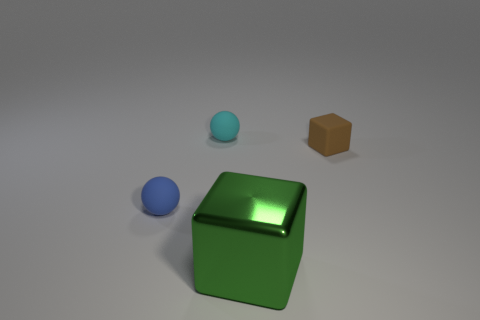How big is the thing that is to the left of the sphere right of the blue rubber sphere?
Offer a terse response. Small. How many brown things have the same shape as the tiny blue rubber object?
Provide a succinct answer. 0. Is the color of the big metal cube the same as the small matte cube?
Give a very brief answer. No. Are there any other things that have the same shape as the blue object?
Keep it short and to the point. Yes. Are there any small matte cubes of the same color as the metallic cube?
Give a very brief answer. No. Is the material of the small sphere in front of the tiny brown rubber block the same as the cube on the left side of the brown rubber block?
Your response must be concise. No. What is the color of the big shiny block?
Give a very brief answer. Green. There is a block that is in front of the small matte thing left of the tiny object that is behind the brown matte thing; what size is it?
Offer a terse response. Large. What number of other things are the same size as the green shiny object?
Keep it short and to the point. 0. How many balls are made of the same material as the brown cube?
Offer a terse response. 2. 